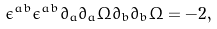<formula> <loc_0><loc_0><loc_500><loc_500>\epsilon ^ { a b } \epsilon ^ { \bar { a } \bar { b } } \partial _ { a } \bar { \partial } _ { \bar { a } } \Omega \partial _ { b } \bar { \partial } _ { \bar { b } } \Omega = - 2 ,</formula> 